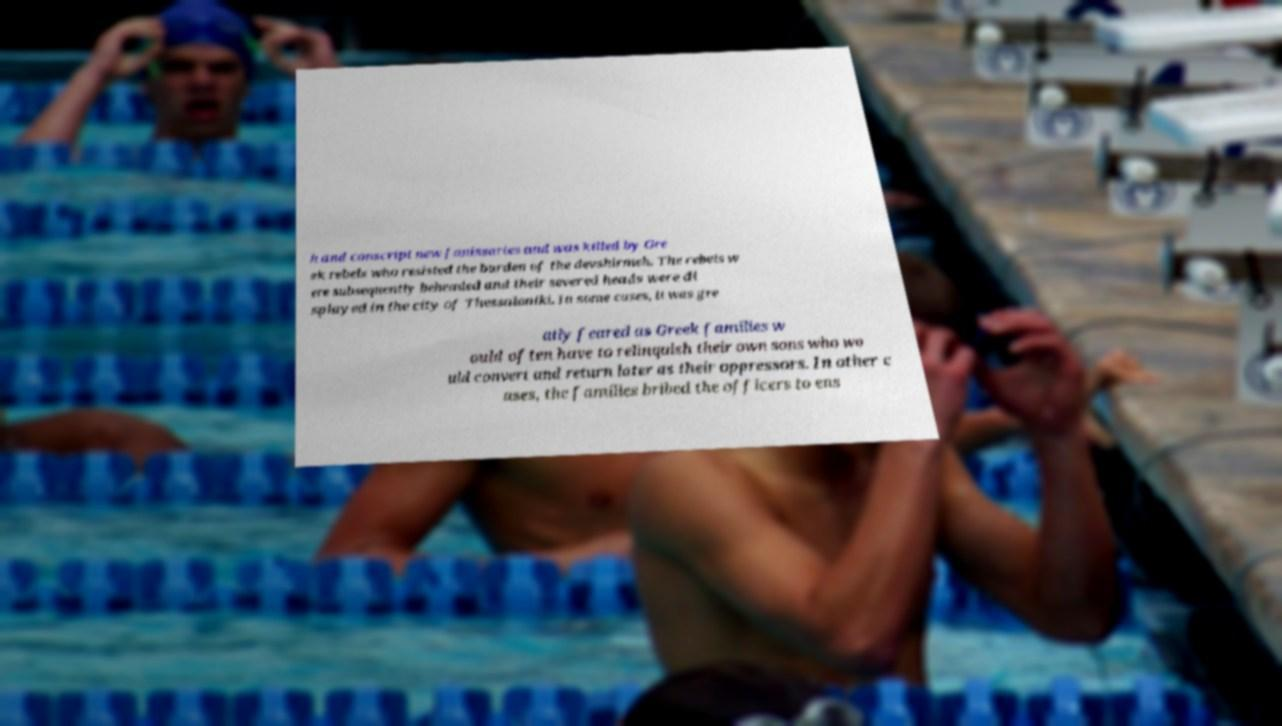Could you extract and type out the text from this image? h and conscript new Janissaries and was killed by Gre ek rebels who resisted the burden of the devshirmeh. The rebels w ere subsequently beheaded and their severed heads were di splayed in the city of Thessaloniki. In some cases, it was gre atly feared as Greek families w ould often have to relinquish their own sons who wo uld convert and return later as their oppressors. In other c ases, the families bribed the officers to ens 